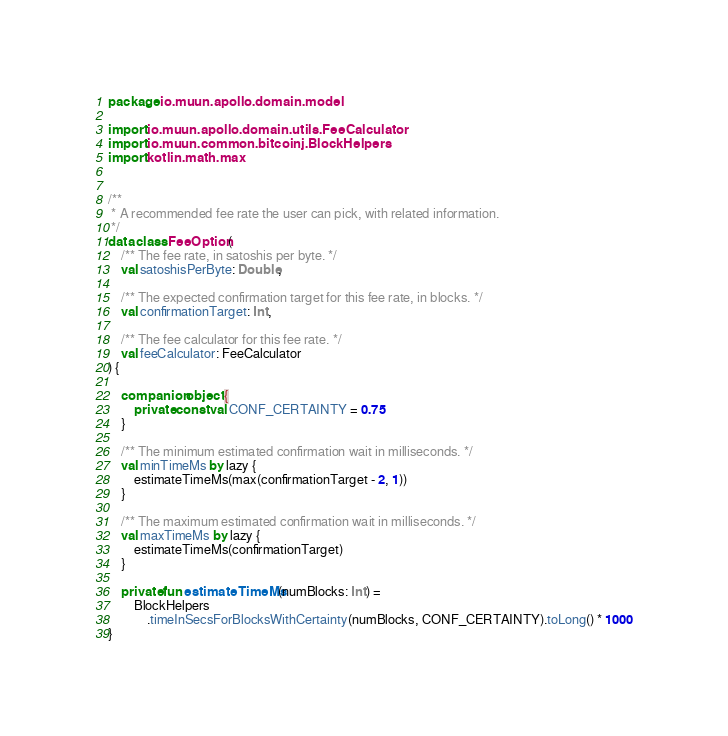Convert code to text. <code><loc_0><loc_0><loc_500><loc_500><_Kotlin_>package io.muun.apollo.domain.model

import io.muun.apollo.domain.utils.FeeCalculator
import io.muun.common.bitcoinj.BlockHelpers
import kotlin.math.max


/**
 * A recommended fee rate the user can pick, with related information.
 */
data class FeeOption(
    /** The fee rate, in satoshis per byte. */
    val satoshisPerByte: Double,

    /** The expected confirmation target for this fee rate, in blocks. */
    val confirmationTarget: Int,

    /** The fee calculator for this fee rate. */
    val feeCalculator: FeeCalculator
) {

    companion object {
        private const val CONF_CERTAINTY = 0.75
    }

    /** The minimum estimated confirmation wait in milliseconds. */
    val minTimeMs by lazy {
        estimateTimeMs(max(confirmationTarget - 2, 1))
    }

    /** The maximum estimated confirmation wait in milliseconds. */
    val maxTimeMs by lazy {
        estimateTimeMs(confirmationTarget)
    }

    private fun estimateTimeMs(numBlocks: Int) =
        BlockHelpers
            .timeInSecsForBlocksWithCertainty(numBlocks, CONF_CERTAINTY).toLong() * 1000
}
</code> 